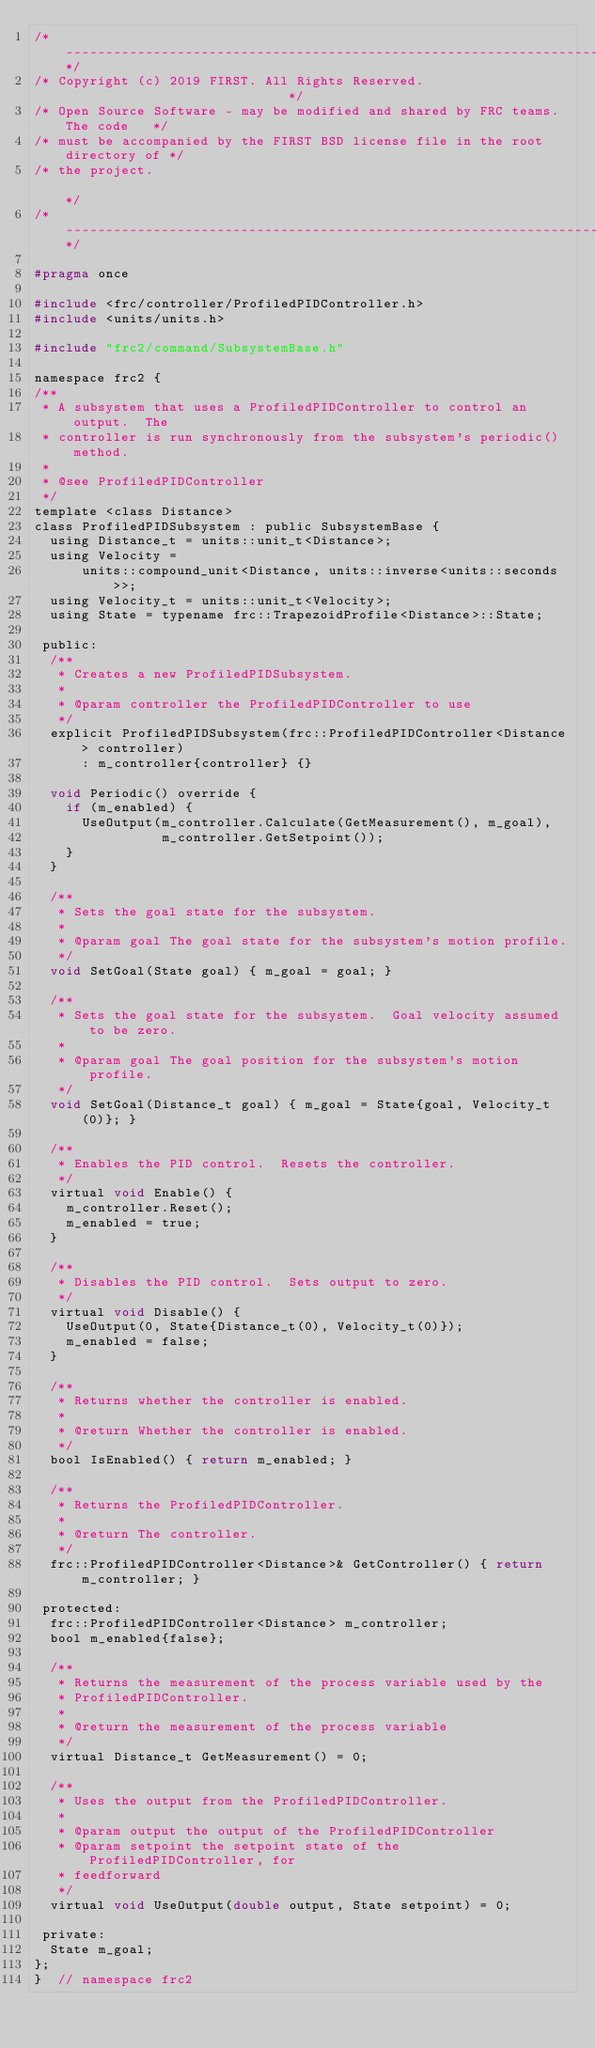<code> <loc_0><loc_0><loc_500><loc_500><_C_>/*----------------------------------------------------------------------------*/
/* Copyright (c) 2019 FIRST. All Rights Reserved.                             */
/* Open Source Software - may be modified and shared by FRC teams. The code   */
/* must be accompanied by the FIRST BSD license file in the root directory of */
/* the project.                                                               */
/*----------------------------------------------------------------------------*/

#pragma once

#include <frc/controller/ProfiledPIDController.h>
#include <units/units.h>

#include "frc2/command/SubsystemBase.h"

namespace frc2 {
/**
 * A subsystem that uses a ProfiledPIDController to control an output.  The
 * controller is run synchronously from the subsystem's periodic() method.
 *
 * @see ProfiledPIDController
 */
template <class Distance>
class ProfiledPIDSubsystem : public SubsystemBase {
  using Distance_t = units::unit_t<Distance>;
  using Velocity =
      units::compound_unit<Distance, units::inverse<units::seconds>>;
  using Velocity_t = units::unit_t<Velocity>;
  using State = typename frc::TrapezoidProfile<Distance>::State;

 public:
  /**
   * Creates a new ProfiledPIDSubsystem.
   *
   * @param controller the ProfiledPIDController to use
   */
  explicit ProfiledPIDSubsystem(frc::ProfiledPIDController<Distance> controller)
      : m_controller{controller} {}

  void Periodic() override {
    if (m_enabled) {
      UseOutput(m_controller.Calculate(GetMeasurement(), m_goal),
                m_controller.GetSetpoint());
    }
  }

  /**
   * Sets the goal state for the subsystem.
   *
   * @param goal The goal state for the subsystem's motion profile.
   */
  void SetGoal(State goal) { m_goal = goal; }

  /**
   * Sets the goal state for the subsystem.  Goal velocity assumed to be zero.
   *
   * @param goal The goal position for the subsystem's motion profile.
   */
  void SetGoal(Distance_t goal) { m_goal = State{goal, Velocity_t(0)}; }

  /**
   * Enables the PID control.  Resets the controller.
   */
  virtual void Enable() {
    m_controller.Reset();
    m_enabled = true;
  }

  /**
   * Disables the PID control.  Sets output to zero.
   */
  virtual void Disable() {
    UseOutput(0, State{Distance_t(0), Velocity_t(0)});
    m_enabled = false;
  }

  /**
   * Returns whether the controller is enabled.
   *
   * @return Whether the controller is enabled.
   */
  bool IsEnabled() { return m_enabled; }

  /**
   * Returns the ProfiledPIDController.
   *
   * @return The controller.
   */
  frc::ProfiledPIDController<Distance>& GetController() { return m_controller; }

 protected:
  frc::ProfiledPIDController<Distance> m_controller;
  bool m_enabled{false};

  /**
   * Returns the measurement of the process variable used by the
   * ProfiledPIDController.
   *
   * @return the measurement of the process variable
   */
  virtual Distance_t GetMeasurement() = 0;

  /**
   * Uses the output from the ProfiledPIDController.
   *
   * @param output the output of the ProfiledPIDController
   * @param setpoint the setpoint state of the ProfiledPIDController, for
   * feedforward
   */
  virtual void UseOutput(double output, State setpoint) = 0;

 private:
  State m_goal;
};
}  // namespace frc2
</code> 